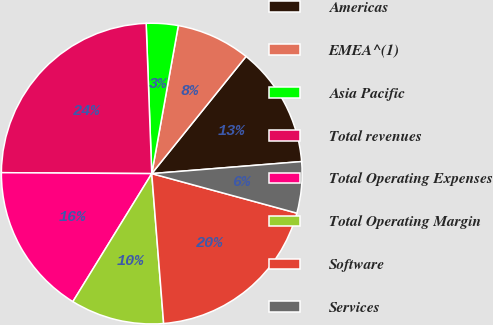<chart> <loc_0><loc_0><loc_500><loc_500><pie_chart><fcel>Americas<fcel>EMEA^(1)<fcel>Asia Pacific<fcel>Total revenues<fcel>Total Operating Expenses<fcel>Total Operating Margin<fcel>Software<fcel>Services<nl><fcel>12.94%<fcel>7.96%<fcel>3.42%<fcel>24.31%<fcel>16.31%<fcel>10.05%<fcel>19.51%<fcel>5.51%<nl></chart> 